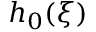Convert formula to latex. <formula><loc_0><loc_0><loc_500><loc_500>h _ { 0 } ( \xi )</formula> 